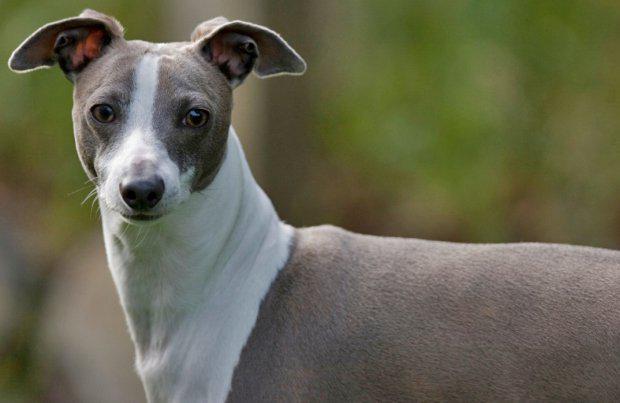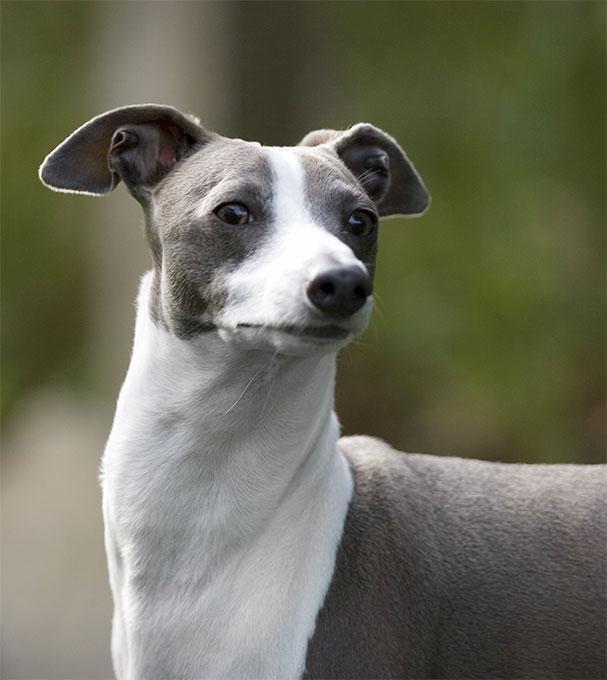The first image is the image on the left, the second image is the image on the right. Assess this claim about the two images: "The right image shows a gray-and-white dog that is craning its neck.". Correct or not? Answer yes or no. Yes. The first image is the image on the left, the second image is the image on the right. For the images displayed, is the sentence "At least one dog is a solid color with no patches of white." factually correct? Answer yes or no. No. 